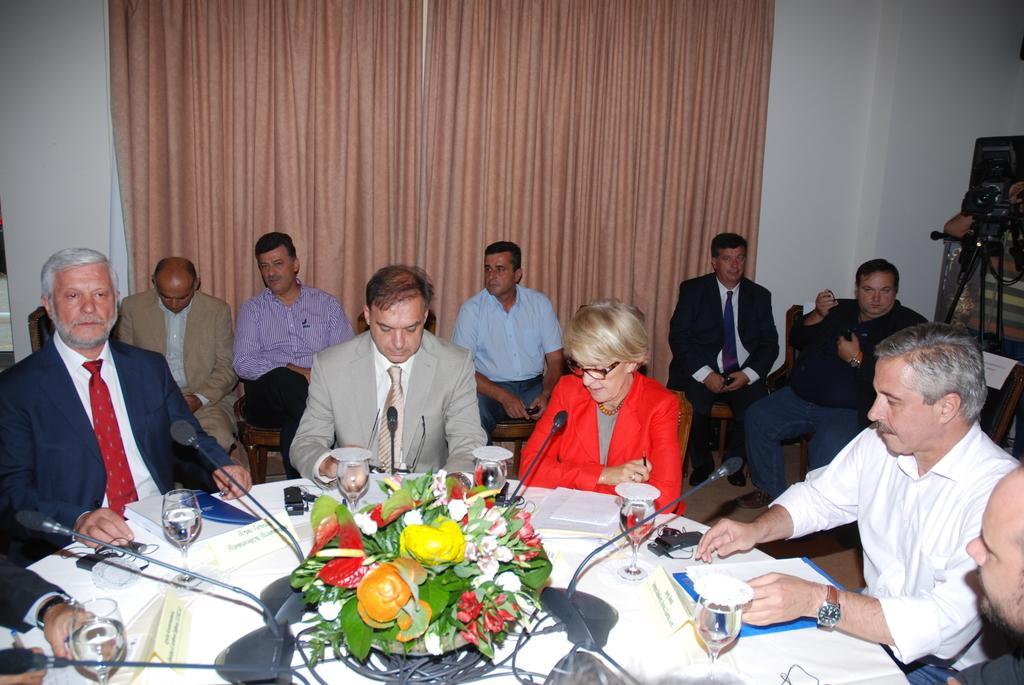In one or two sentences, can you explain what this image depicts? This picture is clicked inside the room. In the center there is a white color table on the top of which a flower vase, books, glasses of water, microphones and some other items are placed and we can see the group of people sitting on the chairs. In the background we can see the wall, curtains and some other objects. 